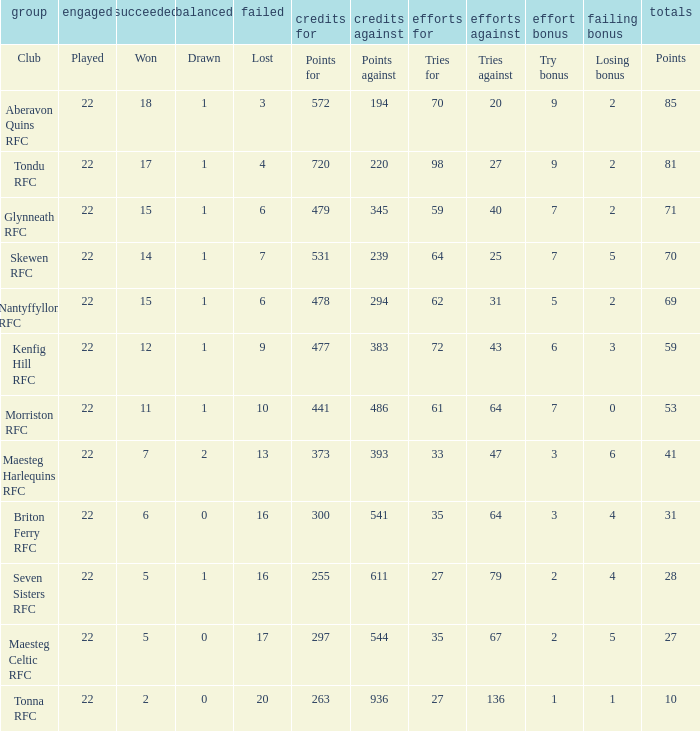What is the value of the points column when the value of the column lost is "lost" Points. 